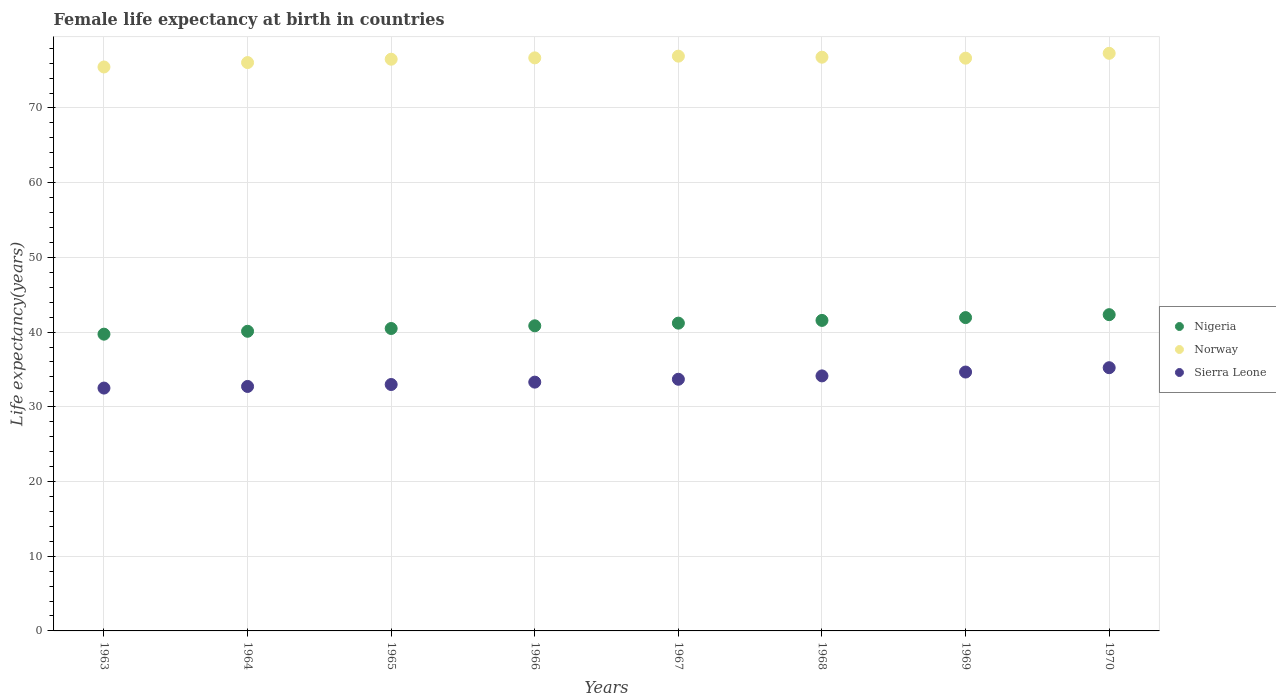What is the female life expectancy at birth in Norway in 1964?
Give a very brief answer. 76.08. Across all years, what is the maximum female life expectancy at birth in Nigeria?
Provide a short and direct response. 42.34. Across all years, what is the minimum female life expectancy at birth in Nigeria?
Your answer should be compact. 39.72. What is the total female life expectancy at birth in Nigeria in the graph?
Your response must be concise. 328.21. What is the difference between the female life expectancy at birth in Norway in 1963 and that in 1970?
Keep it short and to the point. -1.83. What is the difference between the female life expectancy at birth in Sierra Leone in 1966 and the female life expectancy at birth in Norway in 1963?
Keep it short and to the point. -42.19. What is the average female life expectancy at birth in Nigeria per year?
Give a very brief answer. 41.03. In the year 1968, what is the difference between the female life expectancy at birth in Norway and female life expectancy at birth in Sierra Leone?
Your response must be concise. 42.66. In how many years, is the female life expectancy at birth in Norway greater than 48 years?
Provide a succinct answer. 8. What is the ratio of the female life expectancy at birth in Sierra Leone in 1968 to that in 1970?
Your answer should be very brief. 0.97. What is the difference between the highest and the second highest female life expectancy at birth in Nigeria?
Your answer should be very brief. 0.39. What is the difference between the highest and the lowest female life expectancy at birth in Norway?
Offer a terse response. 1.83. In how many years, is the female life expectancy at birth in Norway greater than the average female life expectancy at birth in Norway taken over all years?
Provide a succinct answer. 5. Is it the case that in every year, the sum of the female life expectancy at birth in Nigeria and female life expectancy at birth in Sierra Leone  is greater than the female life expectancy at birth in Norway?
Your answer should be very brief. No. Does the female life expectancy at birth in Norway monotonically increase over the years?
Your answer should be very brief. No. Is the female life expectancy at birth in Sierra Leone strictly greater than the female life expectancy at birth in Nigeria over the years?
Your answer should be compact. No. How many years are there in the graph?
Offer a terse response. 8. What is the difference between two consecutive major ticks on the Y-axis?
Keep it short and to the point. 10. Are the values on the major ticks of Y-axis written in scientific E-notation?
Ensure brevity in your answer.  No. Does the graph contain grids?
Make the answer very short. Yes. Where does the legend appear in the graph?
Offer a terse response. Center right. How many legend labels are there?
Keep it short and to the point. 3. What is the title of the graph?
Keep it short and to the point. Female life expectancy at birth in countries. What is the label or title of the X-axis?
Your response must be concise. Years. What is the label or title of the Y-axis?
Your answer should be very brief. Life expectancy(years). What is the Life expectancy(years) in Nigeria in 1963?
Your answer should be compact. 39.72. What is the Life expectancy(years) of Norway in 1963?
Make the answer very short. 75.49. What is the Life expectancy(years) of Sierra Leone in 1963?
Make the answer very short. 32.51. What is the Life expectancy(years) in Nigeria in 1964?
Make the answer very short. 40.11. What is the Life expectancy(years) in Norway in 1964?
Your answer should be very brief. 76.08. What is the Life expectancy(years) of Sierra Leone in 1964?
Your response must be concise. 32.73. What is the Life expectancy(years) of Nigeria in 1965?
Offer a very short reply. 40.48. What is the Life expectancy(years) of Norway in 1965?
Give a very brief answer. 76.53. What is the Life expectancy(years) of Sierra Leone in 1965?
Your response must be concise. 32.99. What is the Life expectancy(years) of Nigeria in 1966?
Keep it short and to the point. 40.84. What is the Life expectancy(years) of Norway in 1966?
Your response must be concise. 76.71. What is the Life expectancy(years) of Sierra Leone in 1966?
Make the answer very short. 33.3. What is the Life expectancy(years) of Nigeria in 1967?
Offer a terse response. 41.2. What is the Life expectancy(years) of Norway in 1967?
Your answer should be compact. 76.94. What is the Life expectancy(years) in Sierra Leone in 1967?
Offer a terse response. 33.69. What is the Life expectancy(years) in Nigeria in 1968?
Your response must be concise. 41.57. What is the Life expectancy(years) of Norway in 1968?
Ensure brevity in your answer.  76.8. What is the Life expectancy(years) of Sierra Leone in 1968?
Your answer should be compact. 34.14. What is the Life expectancy(years) of Nigeria in 1969?
Provide a succinct answer. 41.94. What is the Life expectancy(years) in Norway in 1969?
Provide a succinct answer. 76.67. What is the Life expectancy(years) of Sierra Leone in 1969?
Offer a terse response. 34.66. What is the Life expectancy(years) in Nigeria in 1970?
Your response must be concise. 42.34. What is the Life expectancy(years) of Norway in 1970?
Ensure brevity in your answer.  77.32. What is the Life expectancy(years) of Sierra Leone in 1970?
Offer a terse response. 35.23. Across all years, what is the maximum Life expectancy(years) of Nigeria?
Offer a very short reply. 42.34. Across all years, what is the maximum Life expectancy(years) of Norway?
Your response must be concise. 77.32. Across all years, what is the maximum Life expectancy(years) of Sierra Leone?
Your answer should be very brief. 35.23. Across all years, what is the minimum Life expectancy(years) of Nigeria?
Ensure brevity in your answer.  39.72. Across all years, what is the minimum Life expectancy(years) of Norway?
Offer a very short reply. 75.49. Across all years, what is the minimum Life expectancy(years) in Sierra Leone?
Your answer should be compact. 32.51. What is the total Life expectancy(years) in Nigeria in the graph?
Keep it short and to the point. 328.21. What is the total Life expectancy(years) of Norway in the graph?
Your response must be concise. 612.54. What is the total Life expectancy(years) of Sierra Leone in the graph?
Ensure brevity in your answer.  269.24. What is the difference between the Life expectancy(years) of Nigeria in 1963 and that in 1964?
Ensure brevity in your answer.  -0.39. What is the difference between the Life expectancy(years) of Norway in 1963 and that in 1964?
Provide a succinct answer. -0.59. What is the difference between the Life expectancy(years) in Sierra Leone in 1963 and that in 1964?
Offer a very short reply. -0.22. What is the difference between the Life expectancy(years) of Nigeria in 1963 and that in 1965?
Offer a very short reply. -0.76. What is the difference between the Life expectancy(years) of Norway in 1963 and that in 1965?
Keep it short and to the point. -1.04. What is the difference between the Life expectancy(years) in Sierra Leone in 1963 and that in 1965?
Provide a short and direct response. -0.48. What is the difference between the Life expectancy(years) in Nigeria in 1963 and that in 1966?
Keep it short and to the point. -1.12. What is the difference between the Life expectancy(years) in Norway in 1963 and that in 1966?
Offer a very short reply. -1.22. What is the difference between the Life expectancy(years) in Sierra Leone in 1963 and that in 1966?
Make the answer very short. -0.8. What is the difference between the Life expectancy(years) of Nigeria in 1963 and that in 1967?
Offer a terse response. -1.48. What is the difference between the Life expectancy(years) in Norway in 1963 and that in 1967?
Your response must be concise. -1.45. What is the difference between the Life expectancy(years) in Sierra Leone in 1963 and that in 1967?
Provide a short and direct response. -1.18. What is the difference between the Life expectancy(years) of Nigeria in 1963 and that in 1968?
Make the answer very short. -1.84. What is the difference between the Life expectancy(years) of Norway in 1963 and that in 1968?
Your response must be concise. -1.31. What is the difference between the Life expectancy(years) in Sierra Leone in 1963 and that in 1968?
Make the answer very short. -1.63. What is the difference between the Life expectancy(years) of Nigeria in 1963 and that in 1969?
Your answer should be compact. -2.22. What is the difference between the Life expectancy(years) in Norway in 1963 and that in 1969?
Your answer should be very brief. -1.18. What is the difference between the Life expectancy(years) in Sierra Leone in 1963 and that in 1969?
Offer a very short reply. -2.15. What is the difference between the Life expectancy(years) of Nigeria in 1963 and that in 1970?
Provide a succinct answer. -2.61. What is the difference between the Life expectancy(years) in Norway in 1963 and that in 1970?
Your response must be concise. -1.83. What is the difference between the Life expectancy(years) in Sierra Leone in 1963 and that in 1970?
Provide a short and direct response. -2.73. What is the difference between the Life expectancy(years) of Nigeria in 1964 and that in 1965?
Give a very brief answer. -0.37. What is the difference between the Life expectancy(years) in Norway in 1964 and that in 1965?
Ensure brevity in your answer.  -0.45. What is the difference between the Life expectancy(years) in Sierra Leone in 1964 and that in 1965?
Your response must be concise. -0.26. What is the difference between the Life expectancy(years) of Nigeria in 1964 and that in 1966?
Offer a very short reply. -0.73. What is the difference between the Life expectancy(years) of Norway in 1964 and that in 1966?
Make the answer very short. -0.63. What is the difference between the Life expectancy(years) in Sierra Leone in 1964 and that in 1966?
Make the answer very short. -0.58. What is the difference between the Life expectancy(years) in Nigeria in 1964 and that in 1967?
Make the answer very short. -1.09. What is the difference between the Life expectancy(years) in Norway in 1964 and that in 1967?
Provide a short and direct response. -0.86. What is the difference between the Life expectancy(years) of Sierra Leone in 1964 and that in 1967?
Your answer should be very brief. -0.96. What is the difference between the Life expectancy(years) in Nigeria in 1964 and that in 1968?
Offer a very short reply. -1.45. What is the difference between the Life expectancy(years) of Norway in 1964 and that in 1968?
Make the answer very short. -0.72. What is the difference between the Life expectancy(years) in Sierra Leone in 1964 and that in 1968?
Ensure brevity in your answer.  -1.41. What is the difference between the Life expectancy(years) of Nigeria in 1964 and that in 1969?
Offer a very short reply. -1.83. What is the difference between the Life expectancy(years) in Norway in 1964 and that in 1969?
Keep it short and to the point. -0.59. What is the difference between the Life expectancy(years) in Sierra Leone in 1964 and that in 1969?
Your answer should be very brief. -1.93. What is the difference between the Life expectancy(years) in Nigeria in 1964 and that in 1970?
Your answer should be very brief. -2.22. What is the difference between the Life expectancy(years) of Norway in 1964 and that in 1970?
Ensure brevity in your answer.  -1.24. What is the difference between the Life expectancy(years) of Sierra Leone in 1964 and that in 1970?
Make the answer very short. -2.51. What is the difference between the Life expectancy(years) of Nigeria in 1965 and that in 1966?
Offer a terse response. -0.36. What is the difference between the Life expectancy(years) in Norway in 1965 and that in 1966?
Your answer should be very brief. -0.18. What is the difference between the Life expectancy(years) of Sierra Leone in 1965 and that in 1966?
Provide a succinct answer. -0.32. What is the difference between the Life expectancy(years) of Nigeria in 1965 and that in 1967?
Your answer should be compact. -0.72. What is the difference between the Life expectancy(years) of Norway in 1965 and that in 1967?
Give a very brief answer. -0.41. What is the difference between the Life expectancy(years) in Sierra Leone in 1965 and that in 1967?
Your response must be concise. -0.7. What is the difference between the Life expectancy(years) of Nigeria in 1965 and that in 1968?
Provide a short and direct response. -1.08. What is the difference between the Life expectancy(years) in Norway in 1965 and that in 1968?
Give a very brief answer. -0.27. What is the difference between the Life expectancy(years) of Sierra Leone in 1965 and that in 1968?
Provide a succinct answer. -1.15. What is the difference between the Life expectancy(years) in Nigeria in 1965 and that in 1969?
Your response must be concise. -1.46. What is the difference between the Life expectancy(years) of Norway in 1965 and that in 1969?
Your answer should be very brief. -0.14. What is the difference between the Life expectancy(years) in Sierra Leone in 1965 and that in 1969?
Your answer should be very brief. -1.67. What is the difference between the Life expectancy(years) in Nigeria in 1965 and that in 1970?
Make the answer very short. -1.85. What is the difference between the Life expectancy(years) in Norway in 1965 and that in 1970?
Your response must be concise. -0.79. What is the difference between the Life expectancy(years) in Sierra Leone in 1965 and that in 1970?
Provide a short and direct response. -2.25. What is the difference between the Life expectancy(years) in Nigeria in 1966 and that in 1967?
Your response must be concise. -0.36. What is the difference between the Life expectancy(years) in Norway in 1966 and that in 1967?
Your response must be concise. -0.23. What is the difference between the Life expectancy(years) in Sierra Leone in 1966 and that in 1967?
Provide a short and direct response. -0.38. What is the difference between the Life expectancy(years) in Nigeria in 1966 and that in 1968?
Keep it short and to the point. -0.72. What is the difference between the Life expectancy(years) in Norway in 1966 and that in 1968?
Your response must be concise. -0.09. What is the difference between the Life expectancy(years) in Sierra Leone in 1966 and that in 1968?
Your answer should be very brief. -0.83. What is the difference between the Life expectancy(years) of Norway in 1966 and that in 1969?
Give a very brief answer. 0.04. What is the difference between the Life expectancy(years) in Sierra Leone in 1966 and that in 1969?
Keep it short and to the point. -1.35. What is the difference between the Life expectancy(years) of Nigeria in 1966 and that in 1970?
Provide a short and direct response. -1.49. What is the difference between the Life expectancy(years) of Norway in 1966 and that in 1970?
Make the answer very short. -0.61. What is the difference between the Life expectancy(years) of Sierra Leone in 1966 and that in 1970?
Your answer should be compact. -1.93. What is the difference between the Life expectancy(years) of Nigeria in 1967 and that in 1968?
Offer a very short reply. -0.36. What is the difference between the Life expectancy(years) of Norway in 1967 and that in 1968?
Offer a terse response. 0.14. What is the difference between the Life expectancy(years) in Sierra Leone in 1967 and that in 1968?
Your response must be concise. -0.45. What is the difference between the Life expectancy(years) in Nigeria in 1967 and that in 1969?
Give a very brief answer. -0.74. What is the difference between the Life expectancy(years) in Norway in 1967 and that in 1969?
Your response must be concise. 0.27. What is the difference between the Life expectancy(years) in Sierra Leone in 1967 and that in 1969?
Offer a very short reply. -0.97. What is the difference between the Life expectancy(years) of Nigeria in 1967 and that in 1970?
Your answer should be compact. -1.13. What is the difference between the Life expectancy(years) in Norway in 1967 and that in 1970?
Your answer should be very brief. -0.38. What is the difference between the Life expectancy(years) of Sierra Leone in 1967 and that in 1970?
Keep it short and to the point. -1.55. What is the difference between the Life expectancy(years) of Nigeria in 1968 and that in 1969?
Provide a short and direct response. -0.38. What is the difference between the Life expectancy(years) of Norway in 1968 and that in 1969?
Offer a terse response. 0.13. What is the difference between the Life expectancy(years) in Sierra Leone in 1968 and that in 1969?
Offer a terse response. -0.52. What is the difference between the Life expectancy(years) in Nigeria in 1968 and that in 1970?
Keep it short and to the point. -0.77. What is the difference between the Life expectancy(years) in Norway in 1968 and that in 1970?
Offer a terse response. -0.52. What is the difference between the Life expectancy(years) of Sierra Leone in 1968 and that in 1970?
Offer a very short reply. -1.1. What is the difference between the Life expectancy(years) of Nigeria in 1969 and that in 1970?
Offer a terse response. -0.39. What is the difference between the Life expectancy(years) of Norway in 1969 and that in 1970?
Give a very brief answer. -0.65. What is the difference between the Life expectancy(years) of Sierra Leone in 1969 and that in 1970?
Provide a succinct answer. -0.58. What is the difference between the Life expectancy(years) of Nigeria in 1963 and the Life expectancy(years) of Norway in 1964?
Offer a terse response. -36.36. What is the difference between the Life expectancy(years) in Nigeria in 1963 and the Life expectancy(years) in Sierra Leone in 1964?
Your answer should be very brief. 7. What is the difference between the Life expectancy(years) of Norway in 1963 and the Life expectancy(years) of Sierra Leone in 1964?
Offer a very short reply. 42.76. What is the difference between the Life expectancy(years) in Nigeria in 1963 and the Life expectancy(years) in Norway in 1965?
Your response must be concise. -36.81. What is the difference between the Life expectancy(years) in Nigeria in 1963 and the Life expectancy(years) in Sierra Leone in 1965?
Provide a succinct answer. 6.74. What is the difference between the Life expectancy(years) in Norway in 1963 and the Life expectancy(years) in Sierra Leone in 1965?
Provide a succinct answer. 42.5. What is the difference between the Life expectancy(years) in Nigeria in 1963 and the Life expectancy(years) in Norway in 1966?
Offer a terse response. -36.99. What is the difference between the Life expectancy(years) in Nigeria in 1963 and the Life expectancy(years) in Sierra Leone in 1966?
Provide a succinct answer. 6.42. What is the difference between the Life expectancy(years) of Norway in 1963 and the Life expectancy(years) of Sierra Leone in 1966?
Your response must be concise. 42.19. What is the difference between the Life expectancy(years) of Nigeria in 1963 and the Life expectancy(years) of Norway in 1967?
Offer a very short reply. -37.22. What is the difference between the Life expectancy(years) of Nigeria in 1963 and the Life expectancy(years) of Sierra Leone in 1967?
Keep it short and to the point. 6.04. What is the difference between the Life expectancy(years) of Norway in 1963 and the Life expectancy(years) of Sierra Leone in 1967?
Your answer should be very brief. 41.8. What is the difference between the Life expectancy(years) of Nigeria in 1963 and the Life expectancy(years) of Norway in 1968?
Offer a terse response. -37.08. What is the difference between the Life expectancy(years) of Nigeria in 1963 and the Life expectancy(years) of Sierra Leone in 1968?
Give a very brief answer. 5.58. What is the difference between the Life expectancy(years) in Norway in 1963 and the Life expectancy(years) in Sierra Leone in 1968?
Offer a terse response. 41.35. What is the difference between the Life expectancy(years) of Nigeria in 1963 and the Life expectancy(years) of Norway in 1969?
Your answer should be compact. -36.95. What is the difference between the Life expectancy(years) of Nigeria in 1963 and the Life expectancy(years) of Sierra Leone in 1969?
Keep it short and to the point. 5.07. What is the difference between the Life expectancy(years) in Norway in 1963 and the Life expectancy(years) in Sierra Leone in 1969?
Offer a terse response. 40.84. What is the difference between the Life expectancy(years) of Nigeria in 1963 and the Life expectancy(years) of Norway in 1970?
Your answer should be compact. -37.6. What is the difference between the Life expectancy(years) of Nigeria in 1963 and the Life expectancy(years) of Sierra Leone in 1970?
Give a very brief answer. 4.49. What is the difference between the Life expectancy(years) in Norway in 1963 and the Life expectancy(years) in Sierra Leone in 1970?
Your response must be concise. 40.26. What is the difference between the Life expectancy(years) in Nigeria in 1964 and the Life expectancy(years) in Norway in 1965?
Provide a short and direct response. -36.42. What is the difference between the Life expectancy(years) of Nigeria in 1964 and the Life expectancy(years) of Sierra Leone in 1965?
Provide a short and direct response. 7.13. What is the difference between the Life expectancy(years) of Norway in 1964 and the Life expectancy(years) of Sierra Leone in 1965?
Your answer should be compact. 43.09. What is the difference between the Life expectancy(years) in Nigeria in 1964 and the Life expectancy(years) in Norway in 1966?
Provide a succinct answer. -36.6. What is the difference between the Life expectancy(years) in Nigeria in 1964 and the Life expectancy(years) in Sierra Leone in 1966?
Ensure brevity in your answer.  6.81. What is the difference between the Life expectancy(years) of Norway in 1964 and the Life expectancy(years) of Sierra Leone in 1966?
Offer a terse response. 42.78. What is the difference between the Life expectancy(years) of Nigeria in 1964 and the Life expectancy(years) of Norway in 1967?
Your answer should be compact. -36.83. What is the difference between the Life expectancy(years) in Nigeria in 1964 and the Life expectancy(years) in Sierra Leone in 1967?
Ensure brevity in your answer.  6.42. What is the difference between the Life expectancy(years) in Norway in 1964 and the Life expectancy(years) in Sierra Leone in 1967?
Ensure brevity in your answer.  42.39. What is the difference between the Life expectancy(years) of Nigeria in 1964 and the Life expectancy(years) of Norway in 1968?
Keep it short and to the point. -36.69. What is the difference between the Life expectancy(years) in Nigeria in 1964 and the Life expectancy(years) in Sierra Leone in 1968?
Provide a short and direct response. 5.97. What is the difference between the Life expectancy(years) in Norway in 1964 and the Life expectancy(years) in Sierra Leone in 1968?
Provide a succinct answer. 41.94. What is the difference between the Life expectancy(years) in Nigeria in 1964 and the Life expectancy(years) in Norway in 1969?
Ensure brevity in your answer.  -36.56. What is the difference between the Life expectancy(years) in Nigeria in 1964 and the Life expectancy(years) in Sierra Leone in 1969?
Your answer should be compact. 5.46. What is the difference between the Life expectancy(years) of Norway in 1964 and the Life expectancy(years) of Sierra Leone in 1969?
Provide a short and direct response. 41.42. What is the difference between the Life expectancy(years) of Nigeria in 1964 and the Life expectancy(years) of Norway in 1970?
Give a very brief answer. -37.21. What is the difference between the Life expectancy(years) of Nigeria in 1964 and the Life expectancy(years) of Sierra Leone in 1970?
Make the answer very short. 4.88. What is the difference between the Life expectancy(years) of Norway in 1964 and the Life expectancy(years) of Sierra Leone in 1970?
Provide a short and direct response. 40.84. What is the difference between the Life expectancy(years) in Nigeria in 1965 and the Life expectancy(years) in Norway in 1966?
Offer a terse response. -36.23. What is the difference between the Life expectancy(years) in Nigeria in 1965 and the Life expectancy(years) in Sierra Leone in 1966?
Offer a very short reply. 7.18. What is the difference between the Life expectancy(years) of Norway in 1965 and the Life expectancy(years) of Sierra Leone in 1966?
Give a very brief answer. 43.23. What is the difference between the Life expectancy(years) in Nigeria in 1965 and the Life expectancy(years) in Norway in 1967?
Give a very brief answer. -36.46. What is the difference between the Life expectancy(years) in Nigeria in 1965 and the Life expectancy(years) in Sierra Leone in 1967?
Give a very brief answer. 6.79. What is the difference between the Life expectancy(years) of Norway in 1965 and the Life expectancy(years) of Sierra Leone in 1967?
Your answer should be compact. 42.84. What is the difference between the Life expectancy(years) of Nigeria in 1965 and the Life expectancy(years) of Norway in 1968?
Your answer should be compact. -36.32. What is the difference between the Life expectancy(years) of Nigeria in 1965 and the Life expectancy(years) of Sierra Leone in 1968?
Offer a very short reply. 6.34. What is the difference between the Life expectancy(years) of Norway in 1965 and the Life expectancy(years) of Sierra Leone in 1968?
Your answer should be very brief. 42.39. What is the difference between the Life expectancy(years) in Nigeria in 1965 and the Life expectancy(years) in Norway in 1969?
Make the answer very short. -36.19. What is the difference between the Life expectancy(years) of Nigeria in 1965 and the Life expectancy(years) of Sierra Leone in 1969?
Provide a short and direct response. 5.83. What is the difference between the Life expectancy(years) in Norway in 1965 and the Life expectancy(years) in Sierra Leone in 1969?
Your response must be concise. 41.88. What is the difference between the Life expectancy(years) of Nigeria in 1965 and the Life expectancy(years) of Norway in 1970?
Ensure brevity in your answer.  -36.84. What is the difference between the Life expectancy(years) in Nigeria in 1965 and the Life expectancy(years) in Sierra Leone in 1970?
Provide a succinct answer. 5.25. What is the difference between the Life expectancy(years) in Norway in 1965 and the Life expectancy(years) in Sierra Leone in 1970?
Keep it short and to the point. 41.3. What is the difference between the Life expectancy(years) in Nigeria in 1966 and the Life expectancy(years) in Norway in 1967?
Make the answer very short. -36.1. What is the difference between the Life expectancy(years) in Nigeria in 1966 and the Life expectancy(years) in Sierra Leone in 1967?
Keep it short and to the point. 7.16. What is the difference between the Life expectancy(years) in Norway in 1966 and the Life expectancy(years) in Sierra Leone in 1967?
Give a very brief answer. 43.02. What is the difference between the Life expectancy(years) in Nigeria in 1966 and the Life expectancy(years) in Norway in 1968?
Provide a short and direct response. -35.96. What is the difference between the Life expectancy(years) in Nigeria in 1966 and the Life expectancy(years) in Sierra Leone in 1968?
Your answer should be compact. 6.7. What is the difference between the Life expectancy(years) of Norway in 1966 and the Life expectancy(years) of Sierra Leone in 1968?
Give a very brief answer. 42.57. What is the difference between the Life expectancy(years) of Nigeria in 1966 and the Life expectancy(years) of Norway in 1969?
Your answer should be very brief. -35.83. What is the difference between the Life expectancy(years) in Nigeria in 1966 and the Life expectancy(years) in Sierra Leone in 1969?
Make the answer very short. 6.19. What is the difference between the Life expectancy(years) in Norway in 1966 and the Life expectancy(years) in Sierra Leone in 1969?
Make the answer very short. 42.05. What is the difference between the Life expectancy(years) of Nigeria in 1966 and the Life expectancy(years) of Norway in 1970?
Provide a short and direct response. -36.48. What is the difference between the Life expectancy(years) of Nigeria in 1966 and the Life expectancy(years) of Sierra Leone in 1970?
Ensure brevity in your answer.  5.61. What is the difference between the Life expectancy(years) of Norway in 1966 and the Life expectancy(years) of Sierra Leone in 1970?
Give a very brief answer. 41.48. What is the difference between the Life expectancy(years) in Nigeria in 1967 and the Life expectancy(years) in Norway in 1968?
Your response must be concise. -35.6. What is the difference between the Life expectancy(years) of Nigeria in 1967 and the Life expectancy(years) of Sierra Leone in 1968?
Offer a terse response. 7.06. What is the difference between the Life expectancy(years) of Norway in 1967 and the Life expectancy(years) of Sierra Leone in 1968?
Your answer should be compact. 42.8. What is the difference between the Life expectancy(years) in Nigeria in 1967 and the Life expectancy(years) in Norway in 1969?
Your answer should be very brief. -35.47. What is the difference between the Life expectancy(years) of Nigeria in 1967 and the Life expectancy(years) of Sierra Leone in 1969?
Keep it short and to the point. 6.55. What is the difference between the Life expectancy(years) in Norway in 1967 and the Life expectancy(years) in Sierra Leone in 1969?
Ensure brevity in your answer.  42.28. What is the difference between the Life expectancy(years) in Nigeria in 1967 and the Life expectancy(years) in Norway in 1970?
Keep it short and to the point. -36.12. What is the difference between the Life expectancy(years) of Nigeria in 1967 and the Life expectancy(years) of Sierra Leone in 1970?
Your response must be concise. 5.97. What is the difference between the Life expectancy(years) in Norway in 1967 and the Life expectancy(years) in Sierra Leone in 1970?
Your response must be concise. 41.7. What is the difference between the Life expectancy(years) of Nigeria in 1968 and the Life expectancy(years) of Norway in 1969?
Provide a short and direct response. -35.1. What is the difference between the Life expectancy(years) in Nigeria in 1968 and the Life expectancy(years) in Sierra Leone in 1969?
Provide a succinct answer. 6.91. What is the difference between the Life expectancy(years) of Norway in 1968 and the Life expectancy(years) of Sierra Leone in 1969?
Provide a short and direct response. 42.15. What is the difference between the Life expectancy(years) of Nigeria in 1968 and the Life expectancy(years) of Norway in 1970?
Give a very brief answer. -35.75. What is the difference between the Life expectancy(years) of Nigeria in 1968 and the Life expectancy(years) of Sierra Leone in 1970?
Make the answer very short. 6.33. What is the difference between the Life expectancy(years) of Norway in 1968 and the Life expectancy(years) of Sierra Leone in 1970?
Your answer should be very brief. 41.56. What is the difference between the Life expectancy(years) in Nigeria in 1969 and the Life expectancy(years) in Norway in 1970?
Make the answer very short. -35.38. What is the difference between the Life expectancy(years) in Nigeria in 1969 and the Life expectancy(years) in Sierra Leone in 1970?
Your answer should be very brief. 6.71. What is the difference between the Life expectancy(years) in Norway in 1969 and the Life expectancy(years) in Sierra Leone in 1970?
Offer a very short reply. 41.44. What is the average Life expectancy(years) in Nigeria per year?
Offer a terse response. 41.03. What is the average Life expectancy(years) in Norway per year?
Your answer should be very brief. 76.57. What is the average Life expectancy(years) in Sierra Leone per year?
Keep it short and to the point. 33.66. In the year 1963, what is the difference between the Life expectancy(years) of Nigeria and Life expectancy(years) of Norway?
Keep it short and to the point. -35.77. In the year 1963, what is the difference between the Life expectancy(years) in Nigeria and Life expectancy(years) in Sierra Leone?
Provide a succinct answer. 7.22. In the year 1963, what is the difference between the Life expectancy(years) of Norway and Life expectancy(years) of Sierra Leone?
Provide a short and direct response. 42.98. In the year 1964, what is the difference between the Life expectancy(years) of Nigeria and Life expectancy(years) of Norway?
Your answer should be very brief. -35.97. In the year 1964, what is the difference between the Life expectancy(years) in Nigeria and Life expectancy(years) in Sierra Leone?
Ensure brevity in your answer.  7.39. In the year 1964, what is the difference between the Life expectancy(years) in Norway and Life expectancy(years) in Sierra Leone?
Make the answer very short. 43.35. In the year 1965, what is the difference between the Life expectancy(years) in Nigeria and Life expectancy(years) in Norway?
Keep it short and to the point. -36.05. In the year 1965, what is the difference between the Life expectancy(years) of Nigeria and Life expectancy(years) of Sierra Leone?
Give a very brief answer. 7.5. In the year 1965, what is the difference between the Life expectancy(years) in Norway and Life expectancy(years) in Sierra Leone?
Your answer should be compact. 43.54. In the year 1966, what is the difference between the Life expectancy(years) in Nigeria and Life expectancy(years) in Norway?
Offer a terse response. -35.87. In the year 1966, what is the difference between the Life expectancy(years) in Nigeria and Life expectancy(years) in Sierra Leone?
Your response must be concise. 7.54. In the year 1966, what is the difference between the Life expectancy(years) of Norway and Life expectancy(years) of Sierra Leone?
Offer a very short reply. 43.41. In the year 1967, what is the difference between the Life expectancy(years) of Nigeria and Life expectancy(years) of Norway?
Give a very brief answer. -35.74. In the year 1967, what is the difference between the Life expectancy(years) of Nigeria and Life expectancy(years) of Sierra Leone?
Your response must be concise. 7.51. In the year 1967, what is the difference between the Life expectancy(years) in Norway and Life expectancy(years) in Sierra Leone?
Ensure brevity in your answer.  43.25. In the year 1968, what is the difference between the Life expectancy(years) in Nigeria and Life expectancy(years) in Norway?
Offer a very short reply. -35.23. In the year 1968, what is the difference between the Life expectancy(years) of Nigeria and Life expectancy(years) of Sierra Leone?
Offer a very short reply. 7.43. In the year 1968, what is the difference between the Life expectancy(years) in Norway and Life expectancy(years) in Sierra Leone?
Your response must be concise. 42.66. In the year 1969, what is the difference between the Life expectancy(years) in Nigeria and Life expectancy(years) in Norway?
Offer a terse response. -34.73. In the year 1969, what is the difference between the Life expectancy(years) of Nigeria and Life expectancy(years) of Sierra Leone?
Keep it short and to the point. 7.29. In the year 1969, what is the difference between the Life expectancy(years) of Norway and Life expectancy(years) of Sierra Leone?
Make the answer very short. 42.02. In the year 1970, what is the difference between the Life expectancy(years) in Nigeria and Life expectancy(years) in Norway?
Your answer should be compact. -34.98. In the year 1970, what is the difference between the Life expectancy(years) of Nigeria and Life expectancy(years) of Sierra Leone?
Provide a short and direct response. 7.1. In the year 1970, what is the difference between the Life expectancy(years) of Norway and Life expectancy(years) of Sierra Leone?
Give a very brief answer. 42.09. What is the ratio of the Life expectancy(years) in Nigeria in 1963 to that in 1964?
Give a very brief answer. 0.99. What is the ratio of the Life expectancy(years) of Nigeria in 1963 to that in 1965?
Make the answer very short. 0.98. What is the ratio of the Life expectancy(years) of Norway in 1963 to that in 1965?
Your response must be concise. 0.99. What is the ratio of the Life expectancy(years) of Sierra Leone in 1963 to that in 1965?
Your answer should be compact. 0.99. What is the ratio of the Life expectancy(years) in Nigeria in 1963 to that in 1966?
Ensure brevity in your answer.  0.97. What is the ratio of the Life expectancy(years) in Norway in 1963 to that in 1966?
Provide a short and direct response. 0.98. What is the ratio of the Life expectancy(years) of Sierra Leone in 1963 to that in 1966?
Give a very brief answer. 0.98. What is the ratio of the Life expectancy(years) of Nigeria in 1963 to that in 1967?
Give a very brief answer. 0.96. What is the ratio of the Life expectancy(years) of Norway in 1963 to that in 1967?
Your response must be concise. 0.98. What is the ratio of the Life expectancy(years) of Sierra Leone in 1963 to that in 1967?
Offer a terse response. 0.96. What is the ratio of the Life expectancy(years) of Nigeria in 1963 to that in 1968?
Provide a short and direct response. 0.96. What is the ratio of the Life expectancy(years) of Norway in 1963 to that in 1968?
Ensure brevity in your answer.  0.98. What is the ratio of the Life expectancy(years) in Sierra Leone in 1963 to that in 1968?
Provide a short and direct response. 0.95. What is the ratio of the Life expectancy(years) in Nigeria in 1963 to that in 1969?
Your response must be concise. 0.95. What is the ratio of the Life expectancy(years) in Norway in 1963 to that in 1969?
Keep it short and to the point. 0.98. What is the ratio of the Life expectancy(years) of Sierra Leone in 1963 to that in 1969?
Offer a very short reply. 0.94. What is the ratio of the Life expectancy(years) of Nigeria in 1963 to that in 1970?
Make the answer very short. 0.94. What is the ratio of the Life expectancy(years) in Norway in 1963 to that in 1970?
Give a very brief answer. 0.98. What is the ratio of the Life expectancy(years) in Sierra Leone in 1963 to that in 1970?
Your answer should be very brief. 0.92. What is the ratio of the Life expectancy(years) of Sierra Leone in 1964 to that in 1965?
Your response must be concise. 0.99. What is the ratio of the Life expectancy(years) of Nigeria in 1964 to that in 1966?
Offer a terse response. 0.98. What is the ratio of the Life expectancy(years) in Sierra Leone in 1964 to that in 1966?
Provide a succinct answer. 0.98. What is the ratio of the Life expectancy(years) of Nigeria in 1964 to that in 1967?
Ensure brevity in your answer.  0.97. What is the ratio of the Life expectancy(years) in Sierra Leone in 1964 to that in 1967?
Your answer should be compact. 0.97. What is the ratio of the Life expectancy(years) of Norway in 1964 to that in 1968?
Your response must be concise. 0.99. What is the ratio of the Life expectancy(years) in Sierra Leone in 1964 to that in 1968?
Offer a terse response. 0.96. What is the ratio of the Life expectancy(years) in Nigeria in 1964 to that in 1969?
Offer a very short reply. 0.96. What is the ratio of the Life expectancy(years) in Sierra Leone in 1964 to that in 1969?
Ensure brevity in your answer.  0.94. What is the ratio of the Life expectancy(years) in Nigeria in 1964 to that in 1970?
Keep it short and to the point. 0.95. What is the ratio of the Life expectancy(years) in Norway in 1964 to that in 1970?
Your answer should be very brief. 0.98. What is the ratio of the Life expectancy(years) of Sierra Leone in 1964 to that in 1970?
Offer a terse response. 0.93. What is the ratio of the Life expectancy(years) in Nigeria in 1965 to that in 1966?
Your answer should be compact. 0.99. What is the ratio of the Life expectancy(years) in Nigeria in 1965 to that in 1967?
Your response must be concise. 0.98. What is the ratio of the Life expectancy(years) of Norway in 1965 to that in 1967?
Provide a short and direct response. 0.99. What is the ratio of the Life expectancy(years) in Sierra Leone in 1965 to that in 1967?
Give a very brief answer. 0.98. What is the ratio of the Life expectancy(years) in Nigeria in 1965 to that in 1968?
Your answer should be very brief. 0.97. What is the ratio of the Life expectancy(years) of Sierra Leone in 1965 to that in 1968?
Provide a short and direct response. 0.97. What is the ratio of the Life expectancy(years) in Nigeria in 1965 to that in 1969?
Offer a terse response. 0.97. What is the ratio of the Life expectancy(years) of Norway in 1965 to that in 1969?
Offer a terse response. 1. What is the ratio of the Life expectancy(years) in Sierra Leone in 1965 to that in 1969?
Your response must be concise. 0.95. What is the ratio of the Life expectancy(years) in Nigeria in 1965 to that in 1970?
Provide a short and direct response. 0.96. What is the ratio of the Life expectancy(years) of Sierra Leone in 1965 to that in 1970?
Ensure brevity in your answer.  0.94. What is the ratio of the Life expectancy(years) of Norway in 1966 to that in 1967?
Your answer should be very brief. 1. What is the ratio of the Life expectancy(years) of Sierra Leone in 1966 to that in 1967?
Your answer should be compact. 0.99. What is the ratio of the Life expectancy(years) of Nigeria in 1966 to that in 1968?
Your answer should be very brief. 0.98. What is the ratio of the Life expectancy(years) in Sierra Leone in 1966 to that in 1968?
Your answer should be very brief. 0.98. What is the ratio of the Life expectancy(years) of Nigeria in 1966 to that in 1969?
Make the answer very short. 0.97. What is the ratio of the Life expectancy(years) in Norway in 1966 to that in 1969?
Ensure brevity in your answer.  1. What is the ratio of the Life expectancy(years) of Sierra Leone in 1966 to that in 1969?
Ensure brevity in your answer.  0.96. What is the ratio of the Life expectancy(years) of Nigeria in 1966 to that in 1970?
Your answer should be compact. 0.96. What is the ratio of the Life expectancy(years) of Norway in 1966 to that in 1970?
Provide a succinct answer. 0.99. What is the ratio of the Life expectancy(years) of Sierra Leone in 1966 to that in 1970?
Offer a terse response. 0.95. What is the ratio of the Life expectancy(years) of Nigeria in 1967 to that in 1968?
Keep it short and to the point. 0.99. What is the ratio of the Life expectancy(years) in Sierra Leone in 1967 to that in 1968?
Your response must be concise. 0.99. What is the ratio of the Life expectancy(years) in Nigeria in 1967 to that in 1969?
Keep it short and to the point. 0.98. What is the ratio of the Life expectancy(years) of Sierra Leone in 1967 to that in 1969?
Your answer should be compact. 0.97. What is the ratio of the Life expectancy(years) of Nigeria in 1967 to that in 1970?
Your answer should be compact. 0.97. What is the ratio of the Life expectancy(years) in Sierra Leone in 1967 to that in 1970?
Give a very brief answer. 0.96. What is the ratio of the Life expectancy(years) in Nigeria in 1968 to that in 1969?
Offer a terse response. 0.99. What is the ratio of the Life expectancy(years) of Sierra Leone in 1968 to that in 1969?
Give a very brief answer. 0.99. What is the ratio of the Life expectancy(years) of Nigeria in 1968 to that in 1970?
Your answer should be very brief. 0.98. What is the ratio of the Life expectancy(years) of Norway in 1968 to that in 1970?
Your answer should be compact. 0.99. What is the ratio of the Life expectancy(years) of Sierra Leone in 1968 to that in 1970?
Give a very brief answer. 0.97. What is the ratio of the Life expectancy(years) in Sierra Leone in 1969 to that in 1970?
Ensure brevity in your answer.  0.98. What is the difference between the highest and the second highest Life expectancy(years) in Nigeria?
Offer a terse response. 0.39. What is the difference between the highest and the second highest Life expectancy(years) in Norway?
Your answer should be very brief. 0.38. What is the difference between the highest and the second highest Life expectancy(years) of Sierra Leone?
Give a very brief answer. 0.58. What is the difference between the highest and the lowest Life expectancy(years) in Nigeria?
Offer a terse response. 2.61. What is the difference between the highest and the lowest Life expectancy(years) of Norway?
Keep it short and to the point. 1.83. What is the difference between the highest and the lowest Life expectancy(years) in Sierra Leone?
Ensure brevity in your answer.  2.73. 